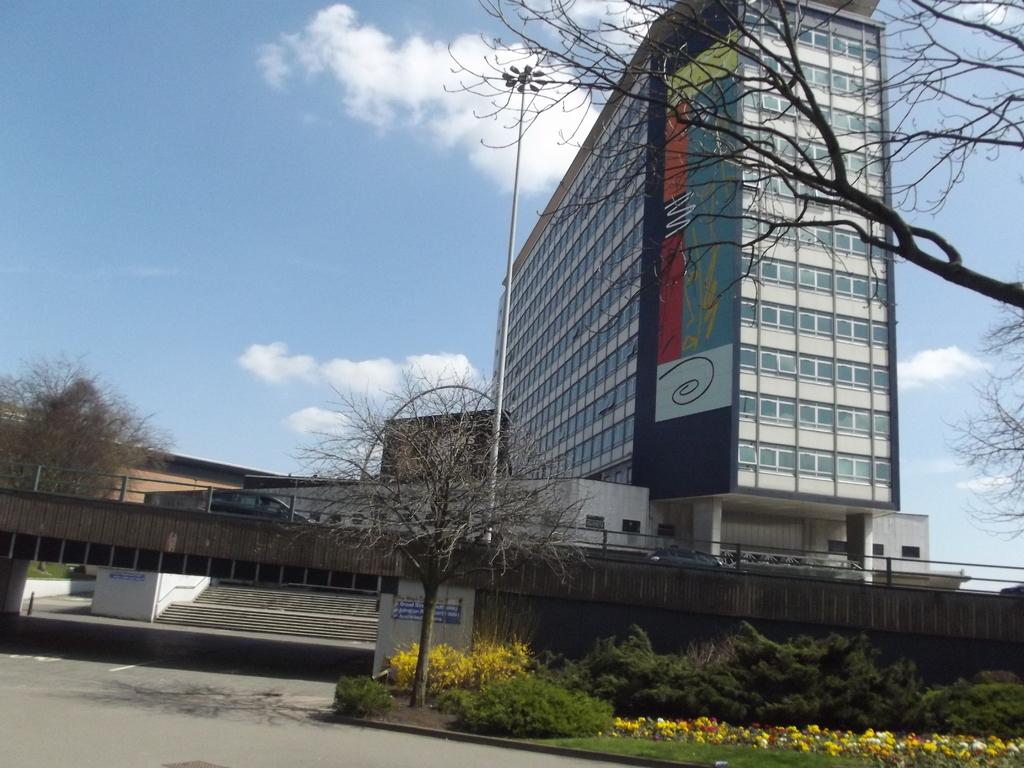What type of structure is present in the image? There is a building in the image. What feature can be seen on the building? The building has windows. What other object is present in the image? There is a light pole in the image. What type of vegetation is visible in the image? There are trees, plants, and grass in the image. What is the condition of the sky in the image? The sky is visible in the image and appears to be cloudy. What else can be found in the image? There is a road in the image. What type of jar can be seen on the road in the image? There is no jar present on the road in the image. What type of cord is attached to the trees in the image? There is no cord attached to the trees in the image. 